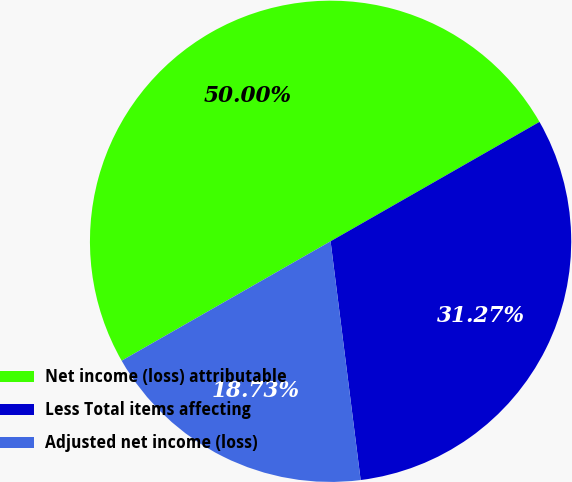Convert chart. <chart><loc_0><loc_0><loc_500><loc_500><pie_chart><fcel>Net income (loss) attributable<fcel>Less Total items affecting<fcel>Adjusted net income (loss)<nl><fcel>50.0%<fcel>31.27%<fcel>18.73%<nl></chart> 